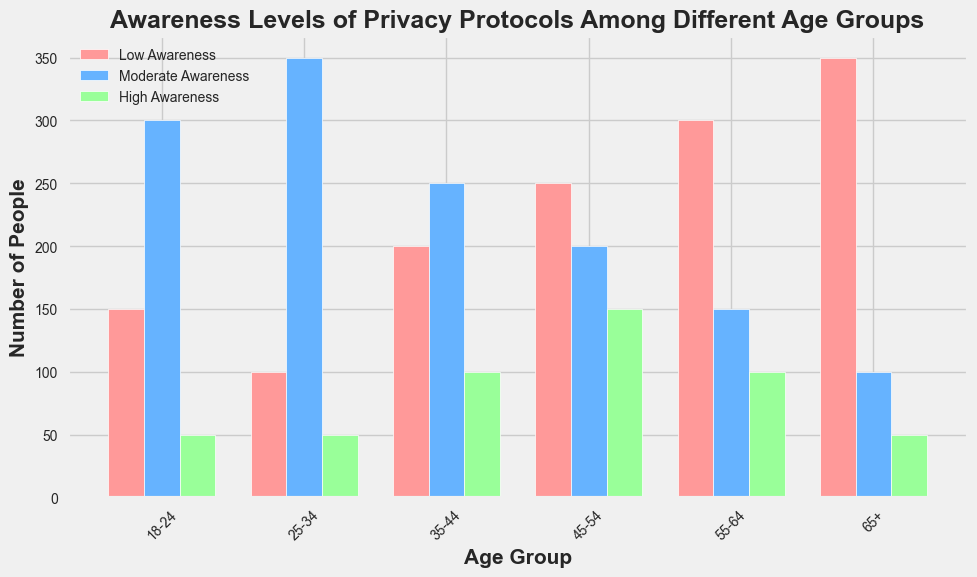Which age group has the highest number of individuals with low awareness? The highest bar in the "Low Awareness" category is for the age group 65+ with 350 individuals.
Answer: 65+ Which age group has the smallest difference between low and high awareness levels? The age group 35-44 has low awareness at 200 and high awareness at 100, giving a difference of 100. Calculating differences for other age groups shows that this is the smallest.
Answer: 35-44 What is the total number of people with moderate awareness in the age groups 18-24 and 25-34 combined? Sum the moderate awareness counts: 300 (18-24) + 350 (25-34) = 650.
Answer: 650 How much greater is the number of individuals with low awareness in the age group 55-64 compared to the age group 25-34? Subtract the low awareness number in 25-34 from 55-64: 300 (55-64) - 100 (25-34) = 200.
Answer: 200 Which age group shows the highest level of high awareness? The tallest bar in the "High Awareness" category is for age group 45-54 with 150 individuals.
Answer: 45-54 What is the average number of individuals with low awareness across all age groups? Sum all low awareness counts and divide by the number of age groups: (150 + 100 + 200 + 250 + 300 + 350) / 6 = 1350 / 6 = 225.
Answer: 225 Is there any age group where the number of individuals with high awareness exceeds the number of individuals with low awareness? No, in all age groups the number of individuals with low awareness is greater than the number of individuals with high awareness.
Answer: No What is the difference between the number of individuals with moderate awareness and those with high awareness in the age group 45-54? Subtract the high awareness number from the moderate awareness number: 200 (moderate) - 150 (high) = 50.
Answer: 50 Which color represents the high awareness levels in the figure? The bars representing high awareness are green.
Answer: Green 